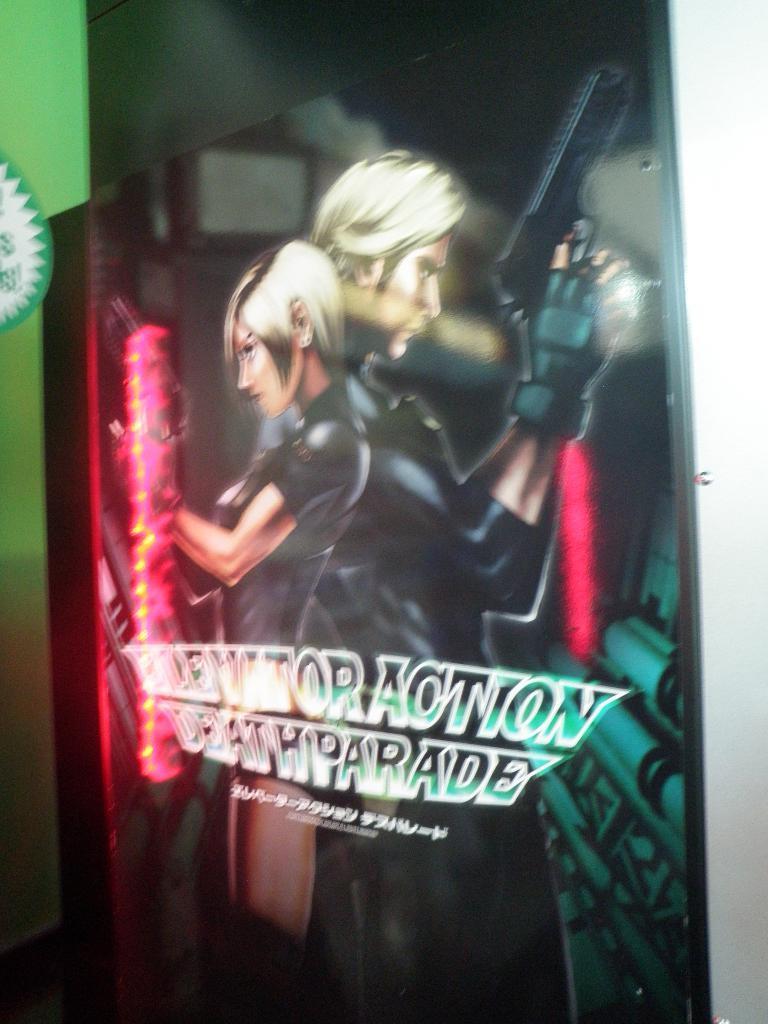Describe this image in one or two sentences. In the picture we can see a poster with a cartoon man and a woman standing with guns and some name on it. 